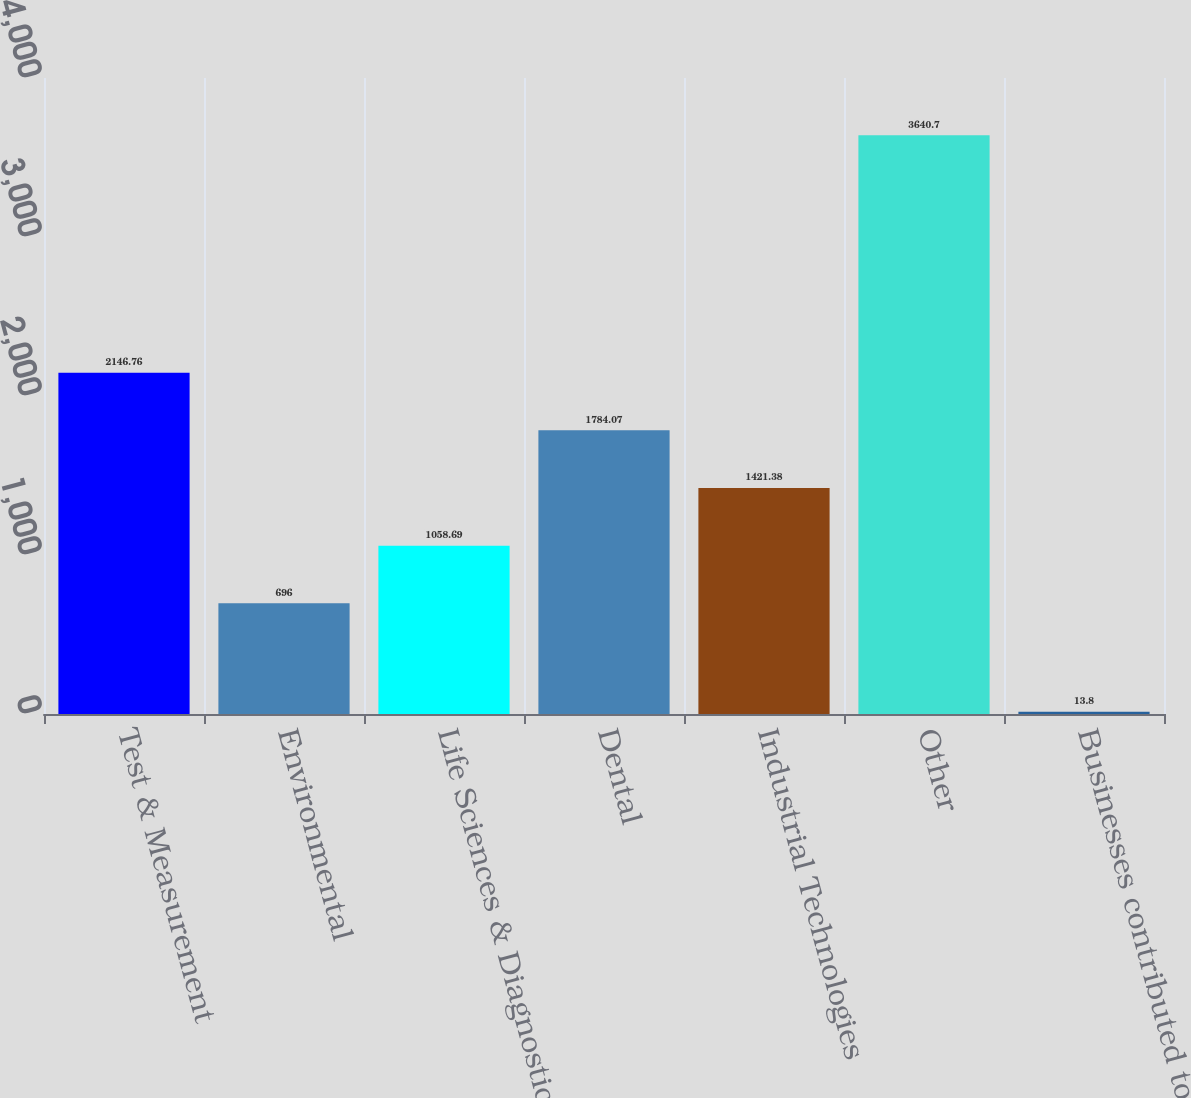<chart> <loc_0><loc_0><loc_500><loc_500><bar_chart><fcel>Test & Measurement<fcel>Environmental<fcel>Life Sciences & Diagnostics<fcel>Dental<fcel>Industrial Technologies<fcel>Other<fcel>Businesses contributed to Apex<nl><fcel>2146.76<fcel>696<fcel>1058.69<fcel>1784.07<fcel>1421.38<fcel>3640.7<fcel>13.8<nl></chart> 